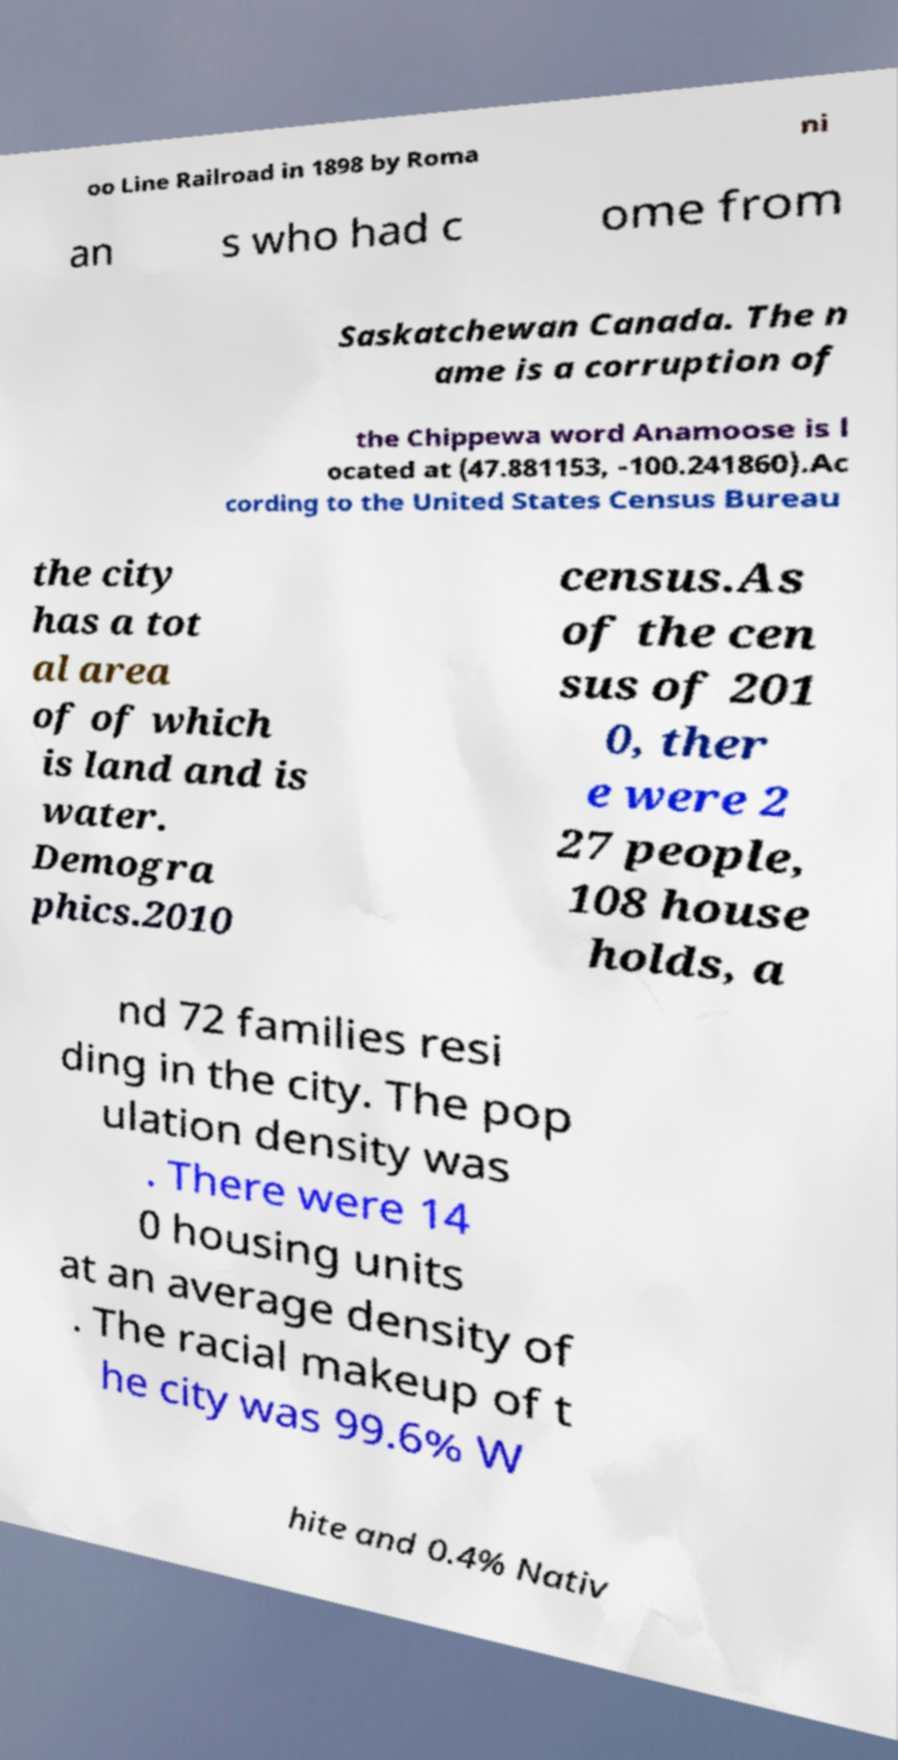Could you assist in decoding the text presented in this image and type it out clearly? oo Line Railroad in 1898 by Roma ni an s who had c ome from Saskatchewan Canada. The n ame is a corruption of the Chippewa word Anamoose is l ocated at (47.881153, -100.241860).Ac cording to the United States Census Bureau the city has a tot al area of of which is land and is water. Demogra phics.2010 census.As of the cen sus of 201 0, ther e were 2 27 people, 108 house holds, a nd 72 families resi ding in the city. The pop ulation density was . There were 14 0 housing units at an average density of . The racial makeup of t he city was 99.6% W hite and 0.4% Nativ 